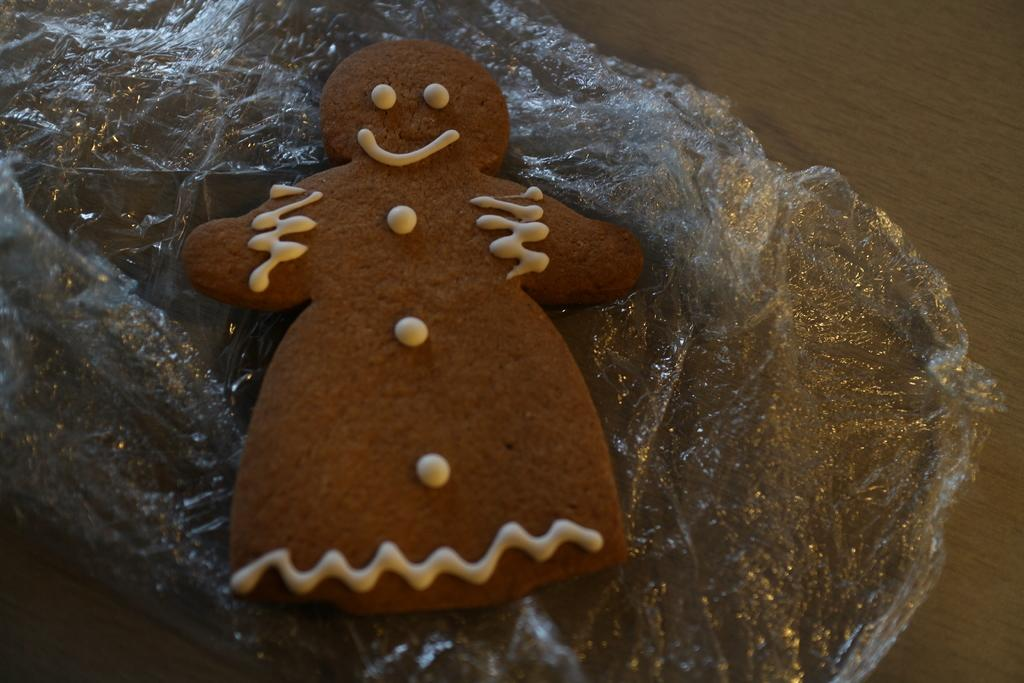What type of food item is visible in the image? There is a brown-colored cookie in the image. How is the cookie placed or positioned in the image? The cookie is kept on a transparent sheet. What type of sail can be seen attached to the cookie in the image? There is no sail present or attached to the cookie in the image. 